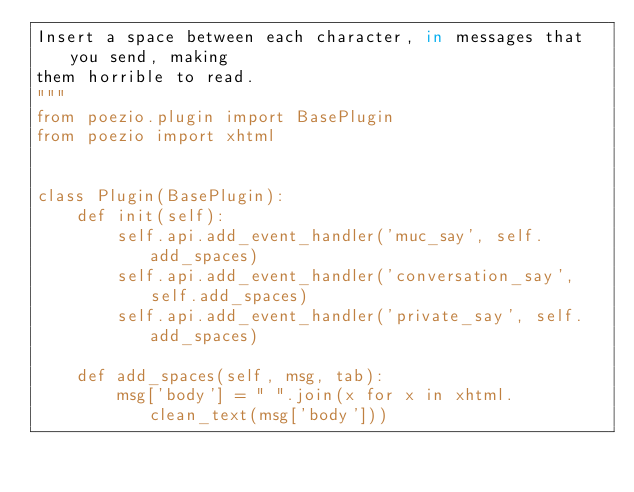Convert code to text. <code><loc_0><loc_0><loc_500><loc_500><_Python_>Insert a space between each character, in messages that you send, making
them horrible to read.
"""
from poezio.plugin import BasePlugin
from poezio import xhtml


class Plugin(BasePlugin):
    def init(self):
        self.api.add_event_handler('muc_say', self.add_spaces)
        self.api.add_event_handler('conversation_say', self.add_spaces)
        self.api.add_event_handler('private_say', self.add_spaces)

    def add_spaces(self, msg, tab):
        msg['body'] = " ".join(x for x in xhtml.clean_text(msg['body']))
</code> 